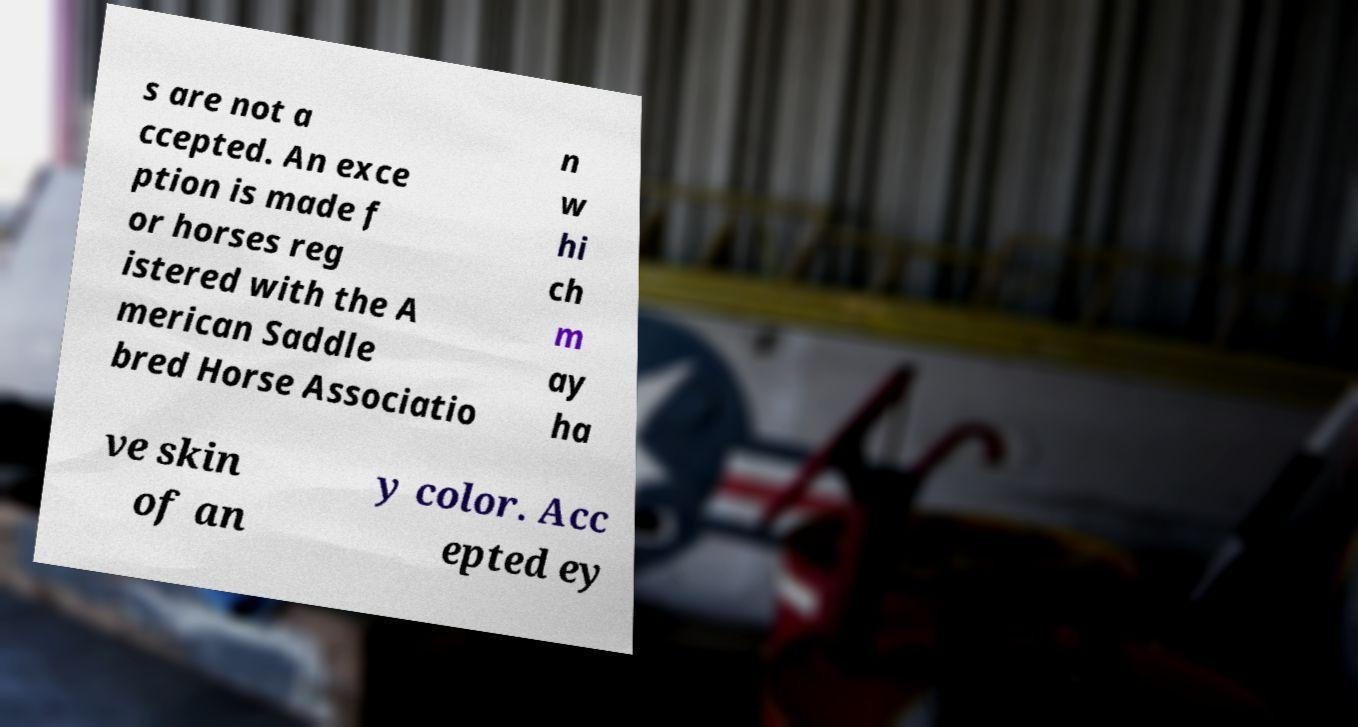Could you extract and type out the text from this image? s are not a ccepted. An exce ption is made f or horses reg istered with the A merican Saddle bred Horse Associatio n w hi ch m ay ha ve skin of an y color. Acc epted ey 